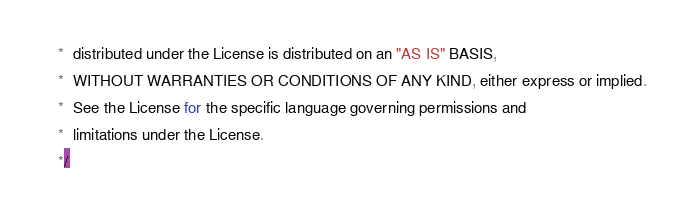Convert code to text. <code><loc_0><loc_0><loc_500><loc_500><_JavaScript_> *  distributed under the License is distributed on an "AS IS" BASIS,
 *  WITHOUT WARRANTIES OR CONDITIONS OF ANY KIND, either express or implied.
 *  See the License for the specific language governing permissions and
 *  limitations under the License.
 */
</code> 